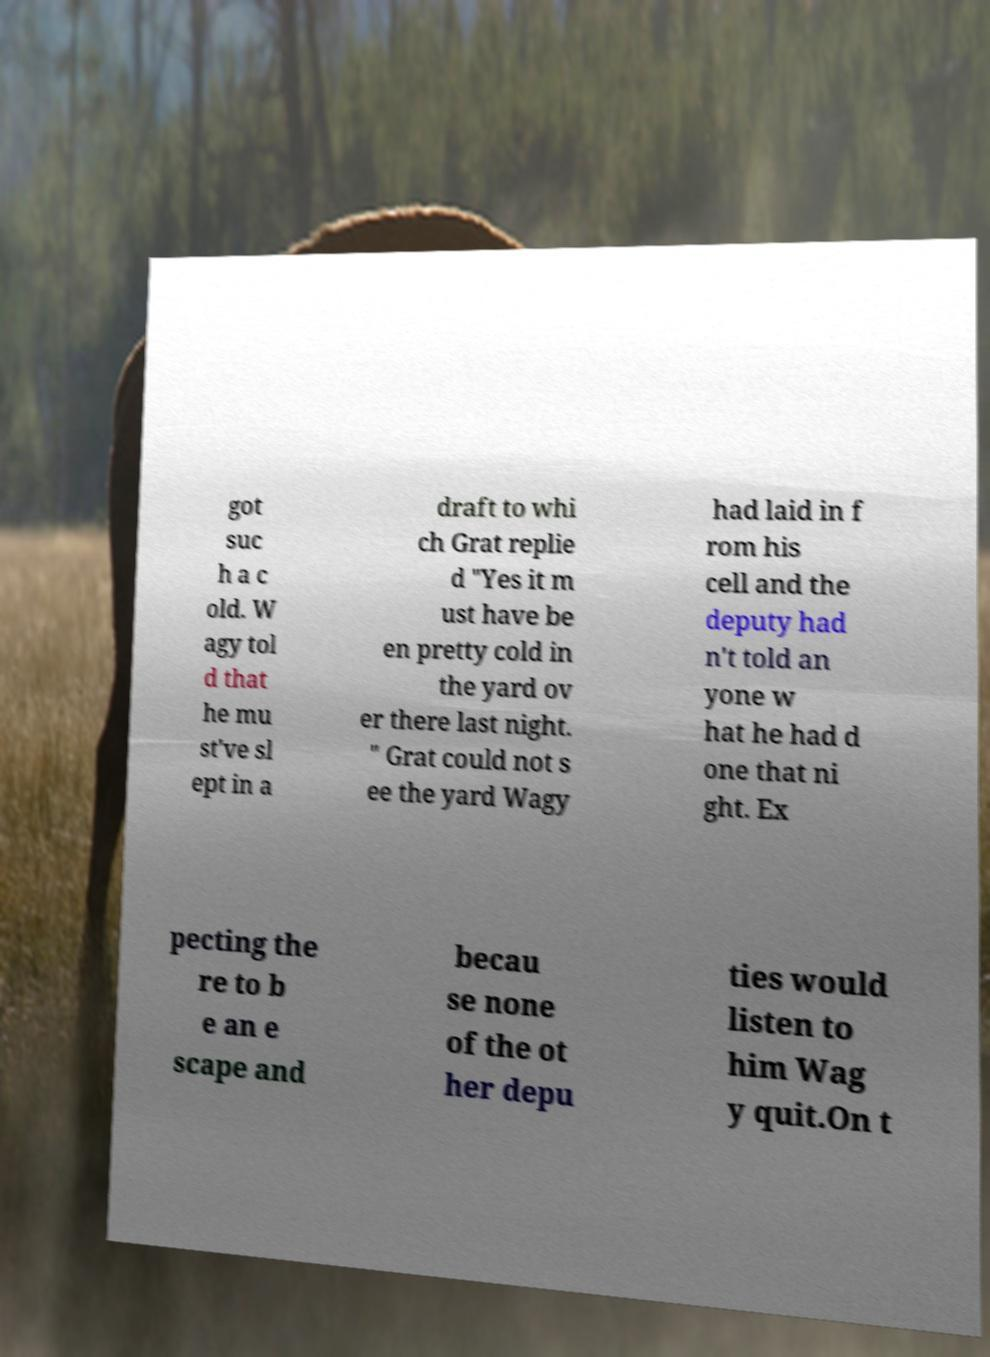I need the written content from this picture converted into text. Can you do that? got suc h a c old. W agy tol d that he mu st've sl ept in a draft to whi ch Grat replie d "Yes it m ust have be en pretty cold in the yard ov er there last night. " Grat could not s ee the yard Wagy had laid in f rom his cell and the deputy had n't told an yone w hat he had d one that ni ght. Ex pecting the re to b e an e scape and becau se none of the ot her depu ties would listen to him Wag y quit.On t 